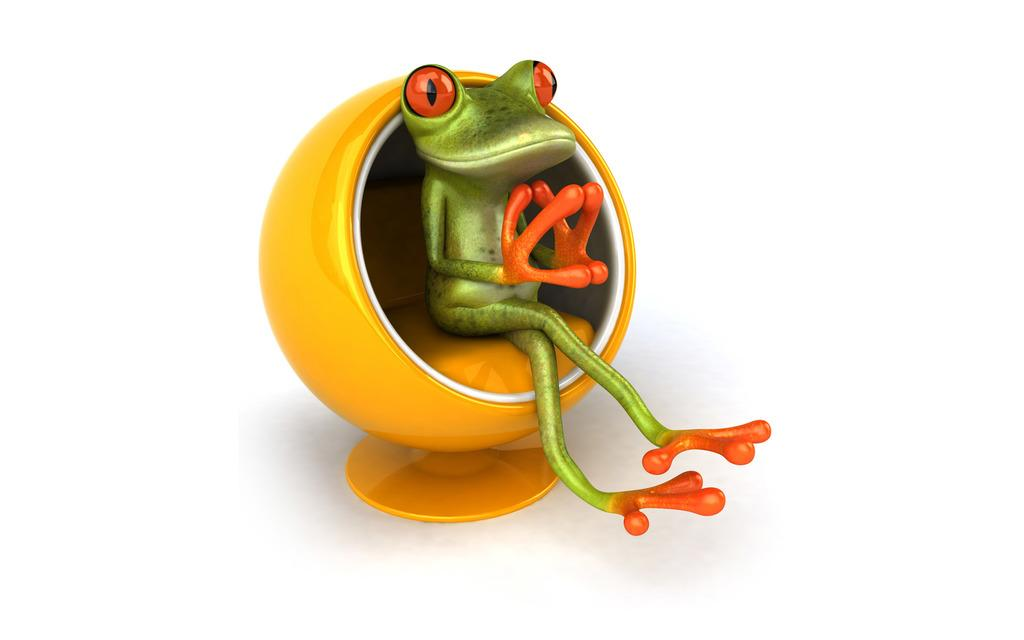What type of image is being described? The image is animated. What animal is present in the image? There is a frog in the image. What is the frog doing in the image? The frog is sitting on a chair. What color is the chair the frog is sitting on? The chair is yellow in color. How many rings does the frog have on its legs in the image? There are no rings visible on the frog's legs in the image. 